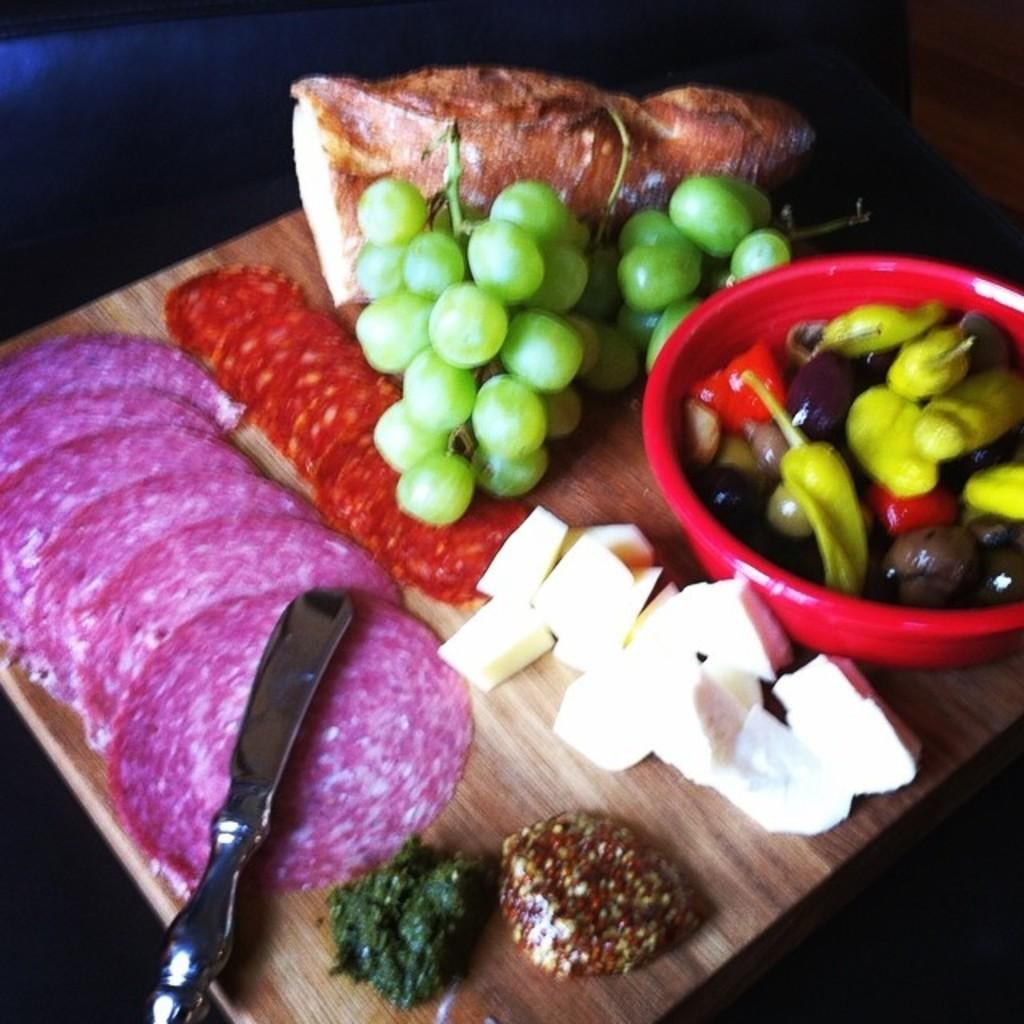What object is present in the image that can hold multiple items? There is a tray in the image that can hold multiple items. What types of food items can be seen in the image? There are food items on the tray and in a bowl in the image. What utensil is present on the tray? There is a knife on the tray. What type of bird can be seen taking a test in the image? There are no birds or tests present in the image. 